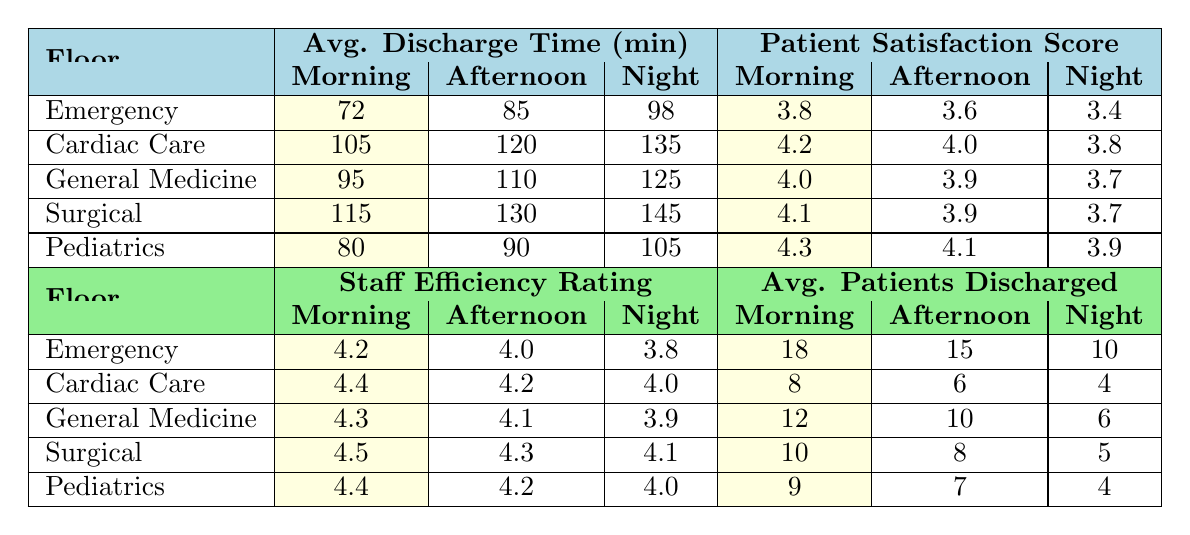What is the average discharge time for the Surgical floor during the Morning shift? The table shows the average discharge time for the Surgical floor during the Morning shift as 115 minutes.
Answer: 115 minutes Which shift has the lowest patient satisfaction score in General Medicine? The table indicates that the Night shift has the lowest patient satisfaction score in General Medicine at 3.7.
Answer: 3.7 What is the average number of patients discharged per shift in the Emergency floor during the Afternoon? According to the table, the average number of patients discharged per shift in the Emergency floor during the Afternoon is 15.
Answer: 15 Is the staff efficiency rating higher during the Morning or the Night shift for the Pediatrics floor? The staff efficiency rating for the Morning shift is 4.4 and for the Night shift is 4.0; therefore, it is higher during the Morning shift.
Answer: Yes For which floor and shift combination is the average discharge time the highest? Looking through the table, the highest average discharge time is for the Surgical floor during the Night shift at 145 minutes.
Answer: Surgical, Night shift What is the difference in patient satisfaction scores between the Morning and Afternoon shifts for Cardiac Care? The patient satisfaction score for the Morning shift in Cardiac Care is 4.2, while for the Afternoon shift it is 4.0. The difference is 4.2 - 4.0 = 0.2.
Answer: 0.2 How many more patients are discharged on average in the Morning shift compared to the Night shift on the General Medicine floor? For the General Medicine floor, 12 patients are discharged on average in the Morning shift and 6 in the Night shift. The difference is 12 - 6 = 6.
Answer: 6 In which department and shift is patient satisfaction the highest? The highest patient satisfaction score is found in Pediatrics during the Morning shift with a score of 4.3.
Answer: Pediatrics, Morning shift What is the average discharge time for the Night shift across all floors? To find the average discharge time for the Night shift, we sum the discharge times: 98 (Emergency) + 135 (Cardiac Care) + 125 (General Medicine) + 145 (Surgical) + 105 (Pediatrics) = 608 minutes. Dividing by 5 (the number of floors), we get 608 / 5 = 121.6 minutes.
Answer: 121.6 minutes Which shift has the highest average discharge time overall, and what is that time? By checking the average discharge times for each shift, the Night shift has the highest total times: 98 (Emergency) + 135 (Cardiac Care) + 125 (General Medicine) + 145 (Surgical) + 105 (Pediatrics) = 608 minutes. The average discharge time for the Night shift is therefore 121.6 minutes.
Answer: 121.6 minutes 